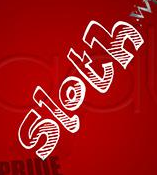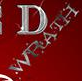What text is displayed in these images sequentially, separated by a semicolon? sloth; WRATH 